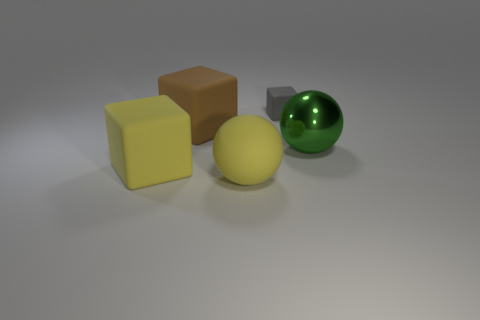Is there anything else that is the same size as the gray object?
Provide a succinct answer. No. What number of other big green objects are the same shape as the big green object?
Provide a short and direct response. 0. Do the big yellow sphere and the green ball that is on the right side of the brown block have the same material?
Your answer should be very brief. No. There is a gray thing that is the same material as the brown cube; what is its size?
Your answer should be very brief. Small. What size is the block that is to the right of the yellow sphere?
Give a very brief answer. Small. How many other spheres are the same size as the green sphere?
Provide a short and direct response. 1. Is there a big object that has the same color as the rubber ball?
Your answer should be compact. Yes. The other matte cube that is the same size as the yellow rubber block is what color?
Offer a very short reply. Brown. There is a shiny thing; does it have the same color as the matte object to the left of the brown thing?
Your answer should be very brief. No. What is the color of the tiny cube?
Provide a succinct answer. Gray. 